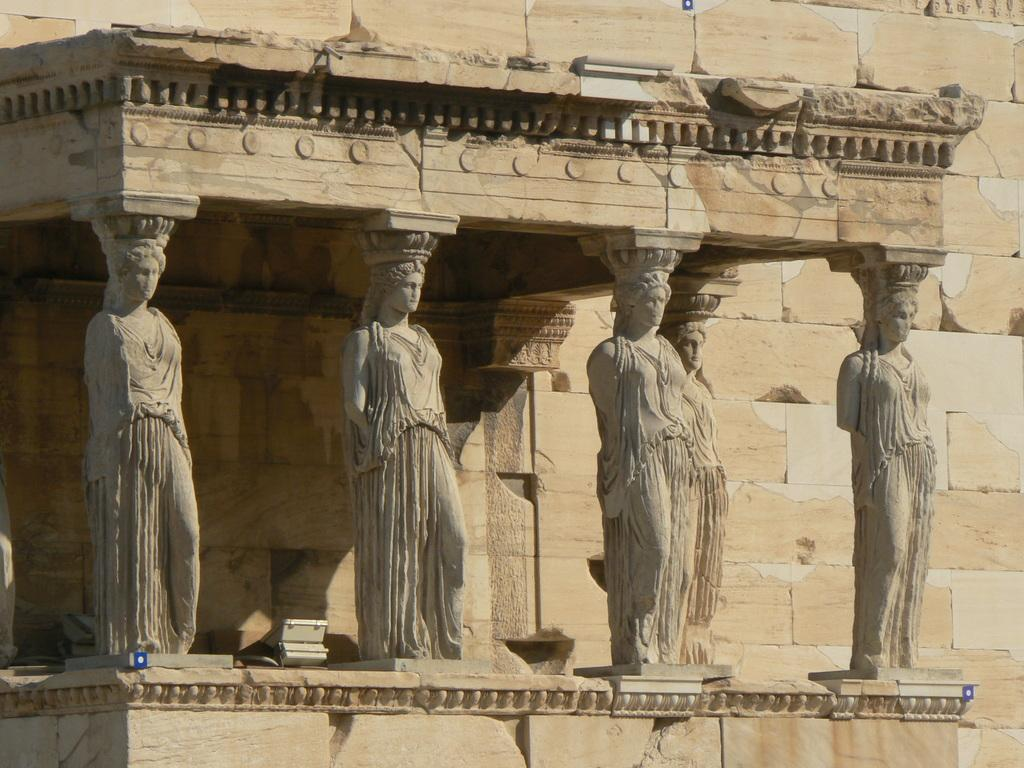What type of objects can be seen in the image? There are statues in the image. Where are the statues located? The statues are attached to a wall. What can be seen in the background of the image? There is a wall visible in the background of the image. What type of camp can be seen in the image? There is no camp present in the image; it features statues attached to a wall. How does the sky appear in the image? The provided facts do not mention the sky, so it cannot be determined from the image. 